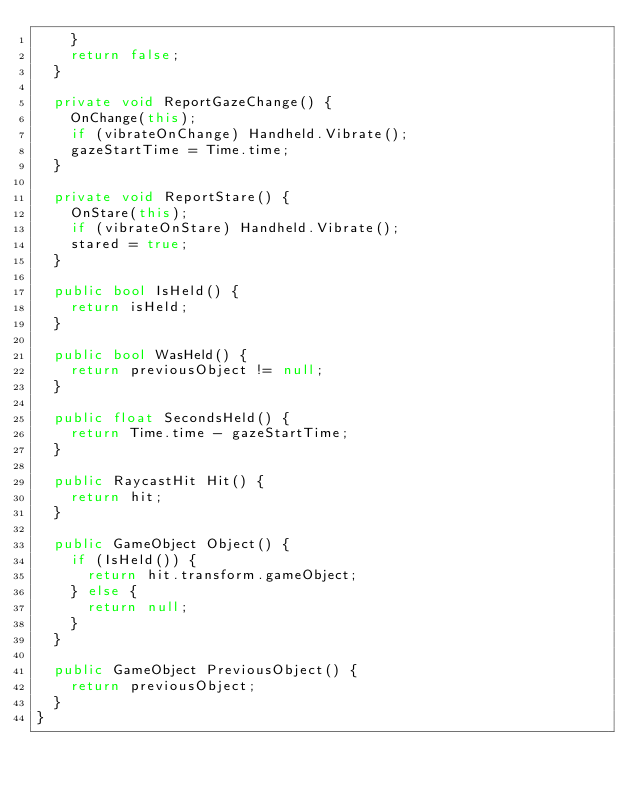Convert code to text. <code><loc_0><loc_0><loc_500><loc_500><_C#_>    }
    return false;
  }

  private void ReportGazeChange() {
    OnChange(this);
    if (vibrateOnChange) Handheld.Vibrate();
    gazeStartTime = Time.time;
  }

  private void ReportStare() {
    OnStare(this);
    if (vibrateOnStare) Handheld.Vibrate();
    stared = true;
  }

  public bool IsHeld() {
    return isHeld;
  }

  public bool WasHeld() {
    return previousObject != null;
  }

  public float SecondsHeld() {
    return Time.time - gazeStartTime;
  }

  public RaycastHit Hit() {
    return hit;
  }

  public GameObject Object() {
    if (IsHeld()) {
      return hit.transform.gameObject;
    } else {
      return null;
    }
  }

  public GameObject PreviousObject() {
    return previousObject;
  }
}
</code> 